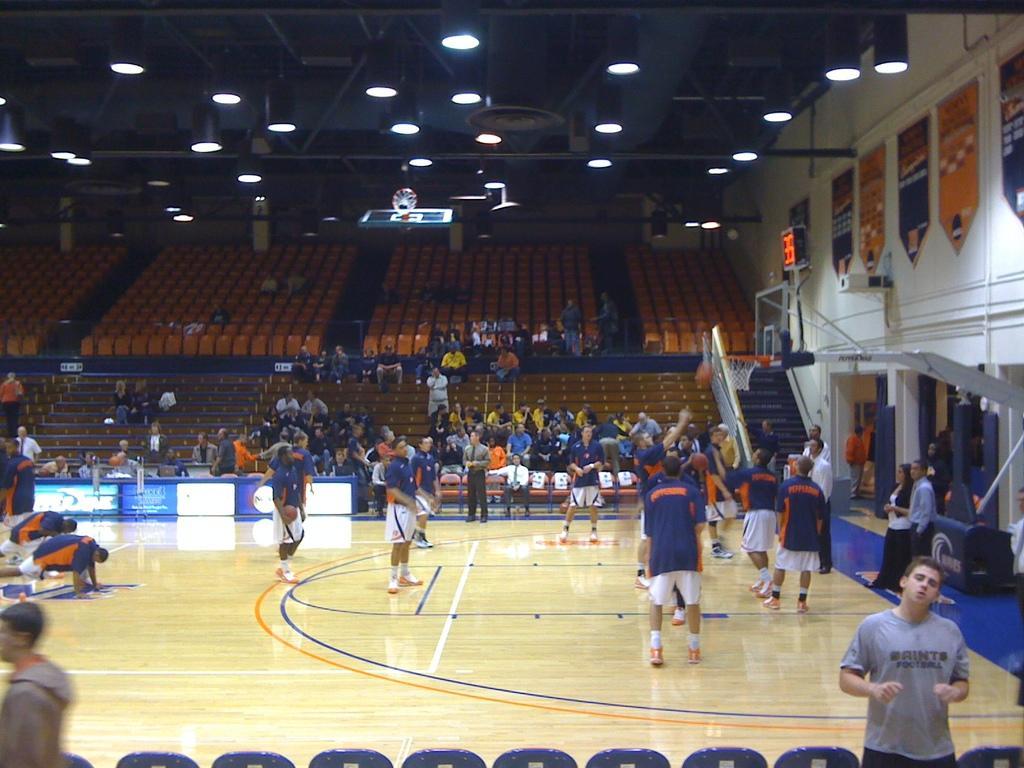How would you summarize this image in a sentence or two? In this image we can see few persons on the basketball court and at the bottom there are objects. In the background we can see people, empty chairs, lights, boards on the wall on the right side, steps, railing and other objects. 